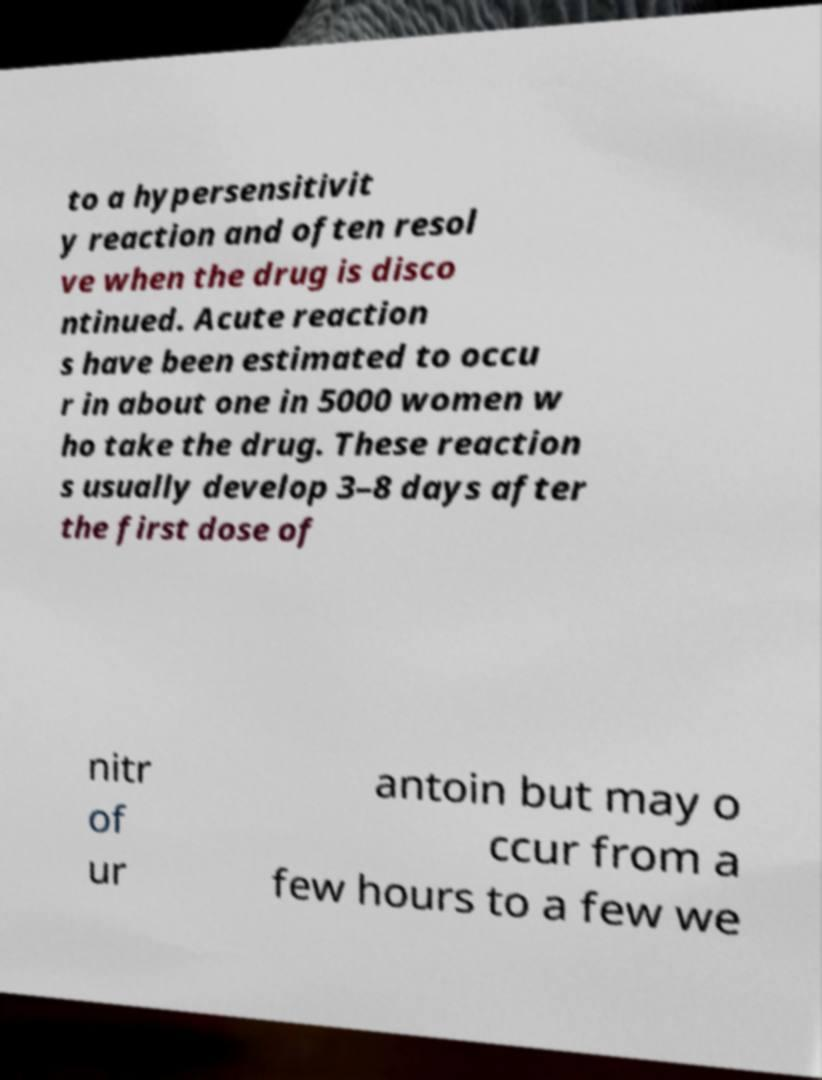Can you read and provide the text displayed in the image?This photo seems to have some interesting text. Can you extract and type it out for me? to a hypersensitivit y reaction and often resol ve when the drug is disco ntinued. Acute reaction s have been estimated to occu r in about one in 5000 women w ho take the drug. These reaction s usually develop 3–8 days after the first dose of nitr of ur antoin but may o ccur from a few hours to a few we 